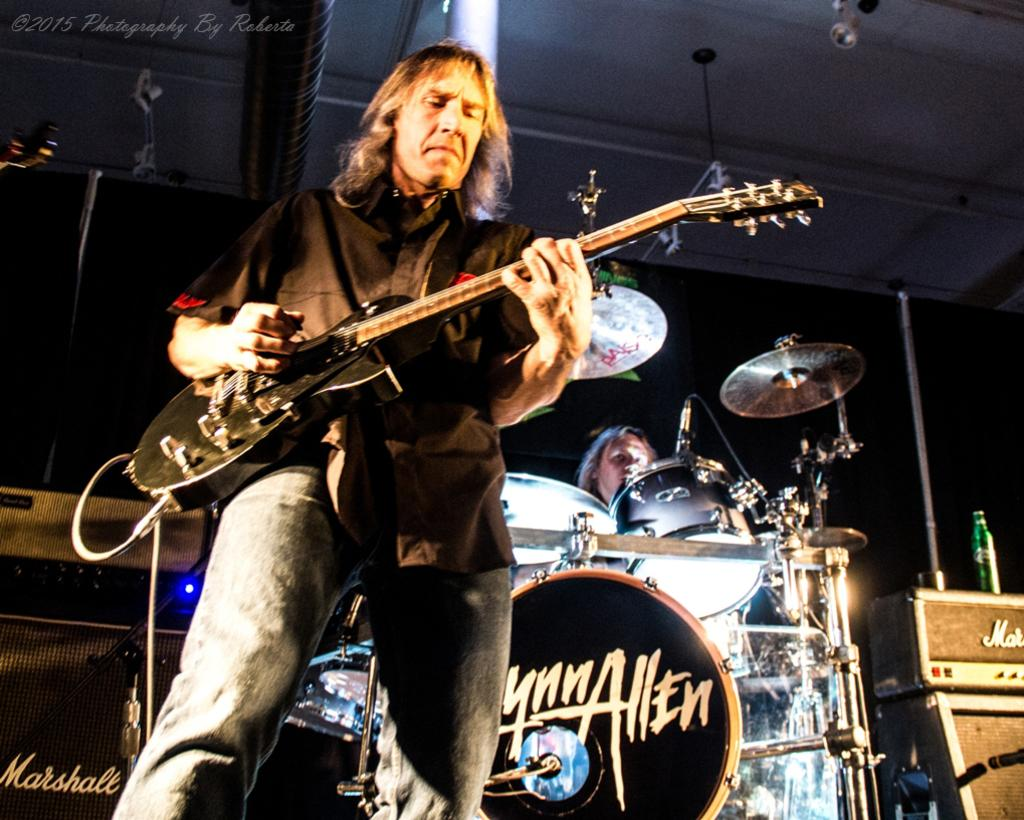How many people are in the image? There are two persons in the image. What are the two people doing in the image? One person is standing and playing a guitar, while the other person is sitting and playing drums. What type of leg is visible in the image? There is no leg visible in the image; it features two people playing musical instruments. How many yards are present in the image? There is no yard present in the image; it is focused on the two people playing instruments. 